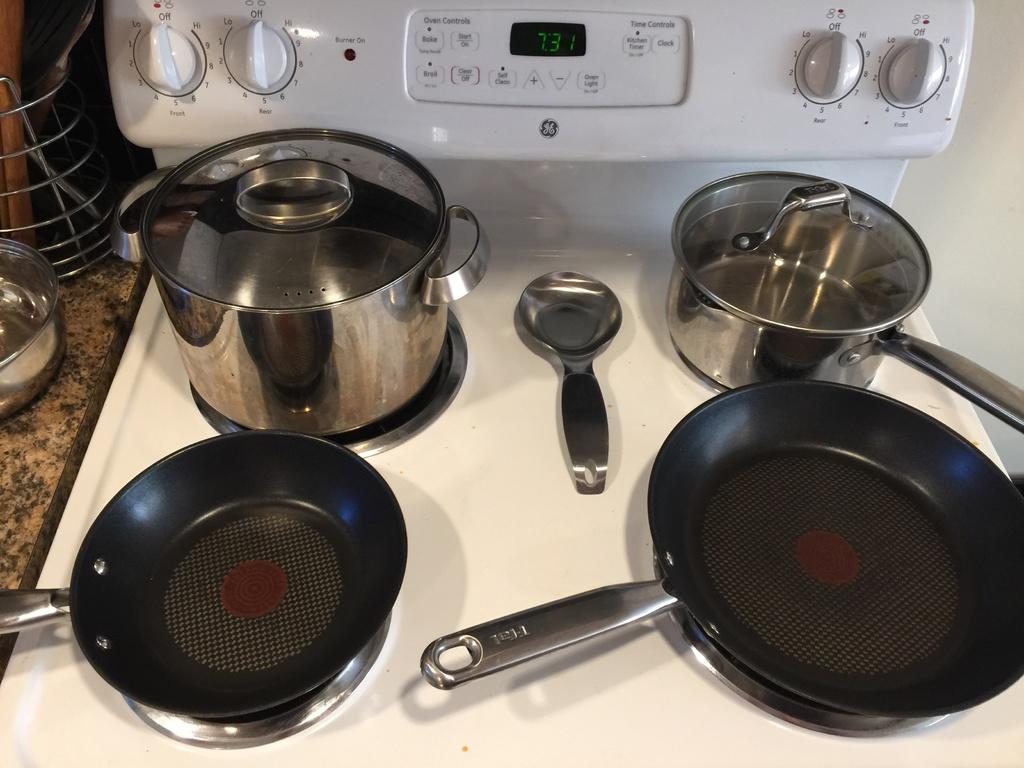What's the number on the timer?
Provide a succinct answer. 7:31. What number is the left dial set to?
Offer a very short reply. Off. 